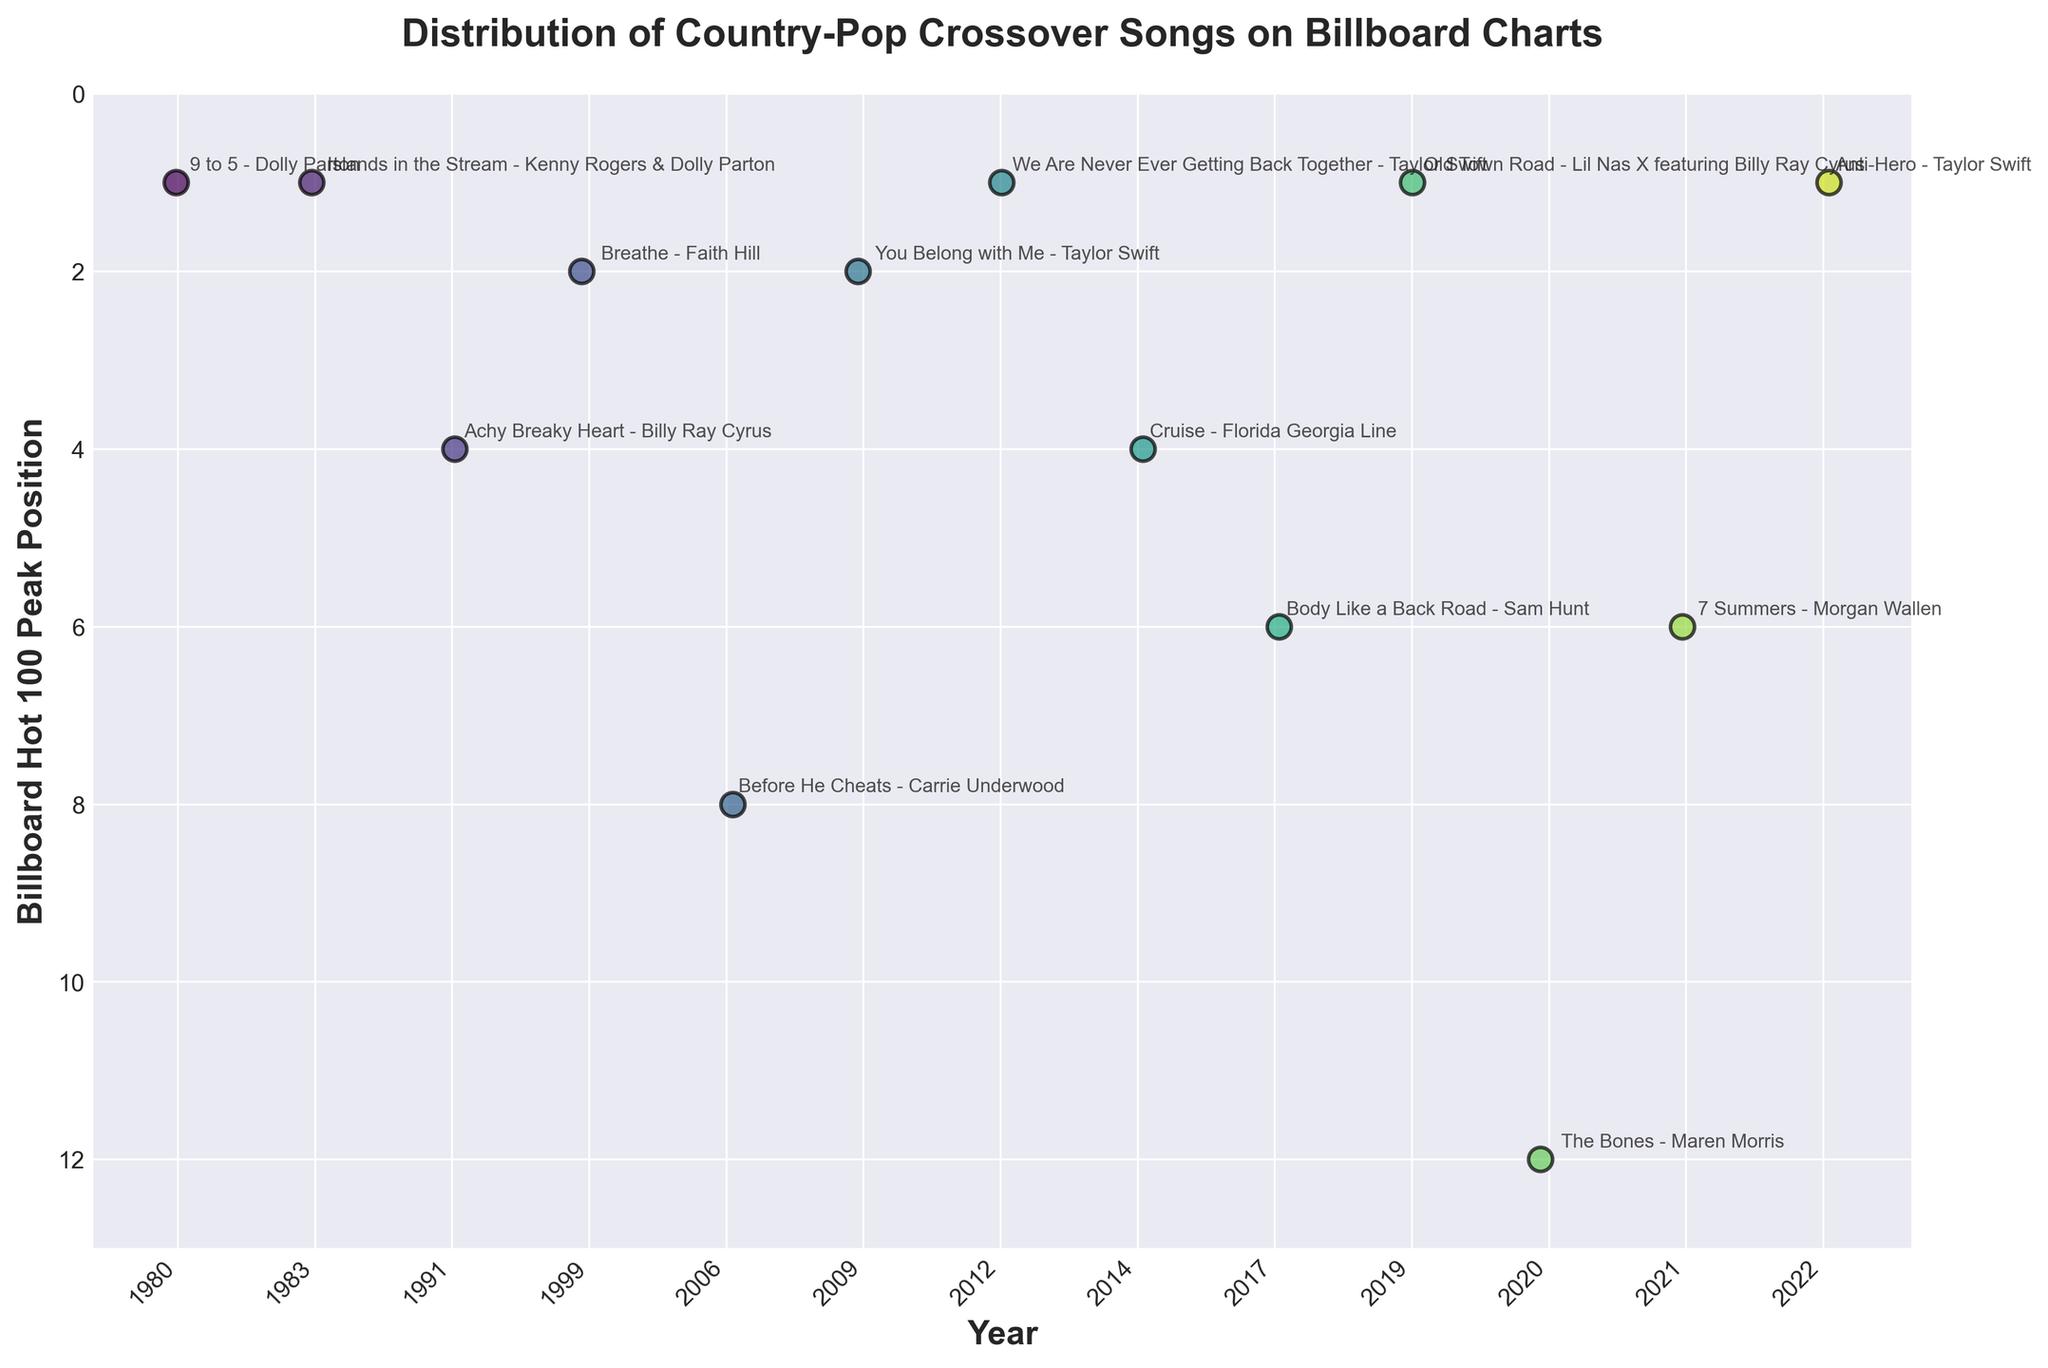What's the title of the plot? The title of the plot is typically at the top center of the figure, written in larger or bold font. It helps to understand what the plot is about at a glance.
Answer: Distribution of Country-Pop Crossover Songs on Billboard Charts What is the peak Billboard Hot 100 position achieved by 'Old Town Road'? Locate 'Old Town Road' in the annotations and identify the peak position on the vertical axis, which is inverted.
Answer: 1 How many songs reached the number one position on the Billboard Hot 100? On the vertical axis, the peak position '1' is at the highest point. Count the number of data points located here.
Answer: 5 Which year has the highest number of entries in the plot? Identify the year with the most data points by counting the entries for each year along the horizontal axis.
Answer: 2022 Which artist has the most songs on the plot? Look at all annotations to see which artist appears most frequently.
Answer: Taylor Swift What is the average Billboard Hot 100 peak position of Taylor Swift's songs on the plot? Identify all Taylor Swift's songs and their respective positions, then calculate the average.
Answer: (2 + 1 + 1) / 3 = 4/3 ≈ 1.33 Between 2000 and 2020, how many songs peaked in the top 5? Count the data points between 2000 and 2020 that have peak positions from 1 to 5.
Answer: 5 Which year had the highest peak position for a song? Look at each year's highest position on the chart. Note that the peak position is lowest in number but highest in status.
Answer: Every year with a song reaching position 1, i.e., 1980, 1983, 2012, 2019, and 2022 Do more songs peak in the top 10 or outside the top 10? Compare the number of data points below position 10 with those above, considering the inverted axis.
Answer: Top 10 Describe the trend in the popularity of country-pop crossover songs over the decades based on the plot. Observe the number of songs and their peak positions by decade to identify any patterns or changes in popularity.
Answer: Increasing in frequency and maintaining high chart positions 